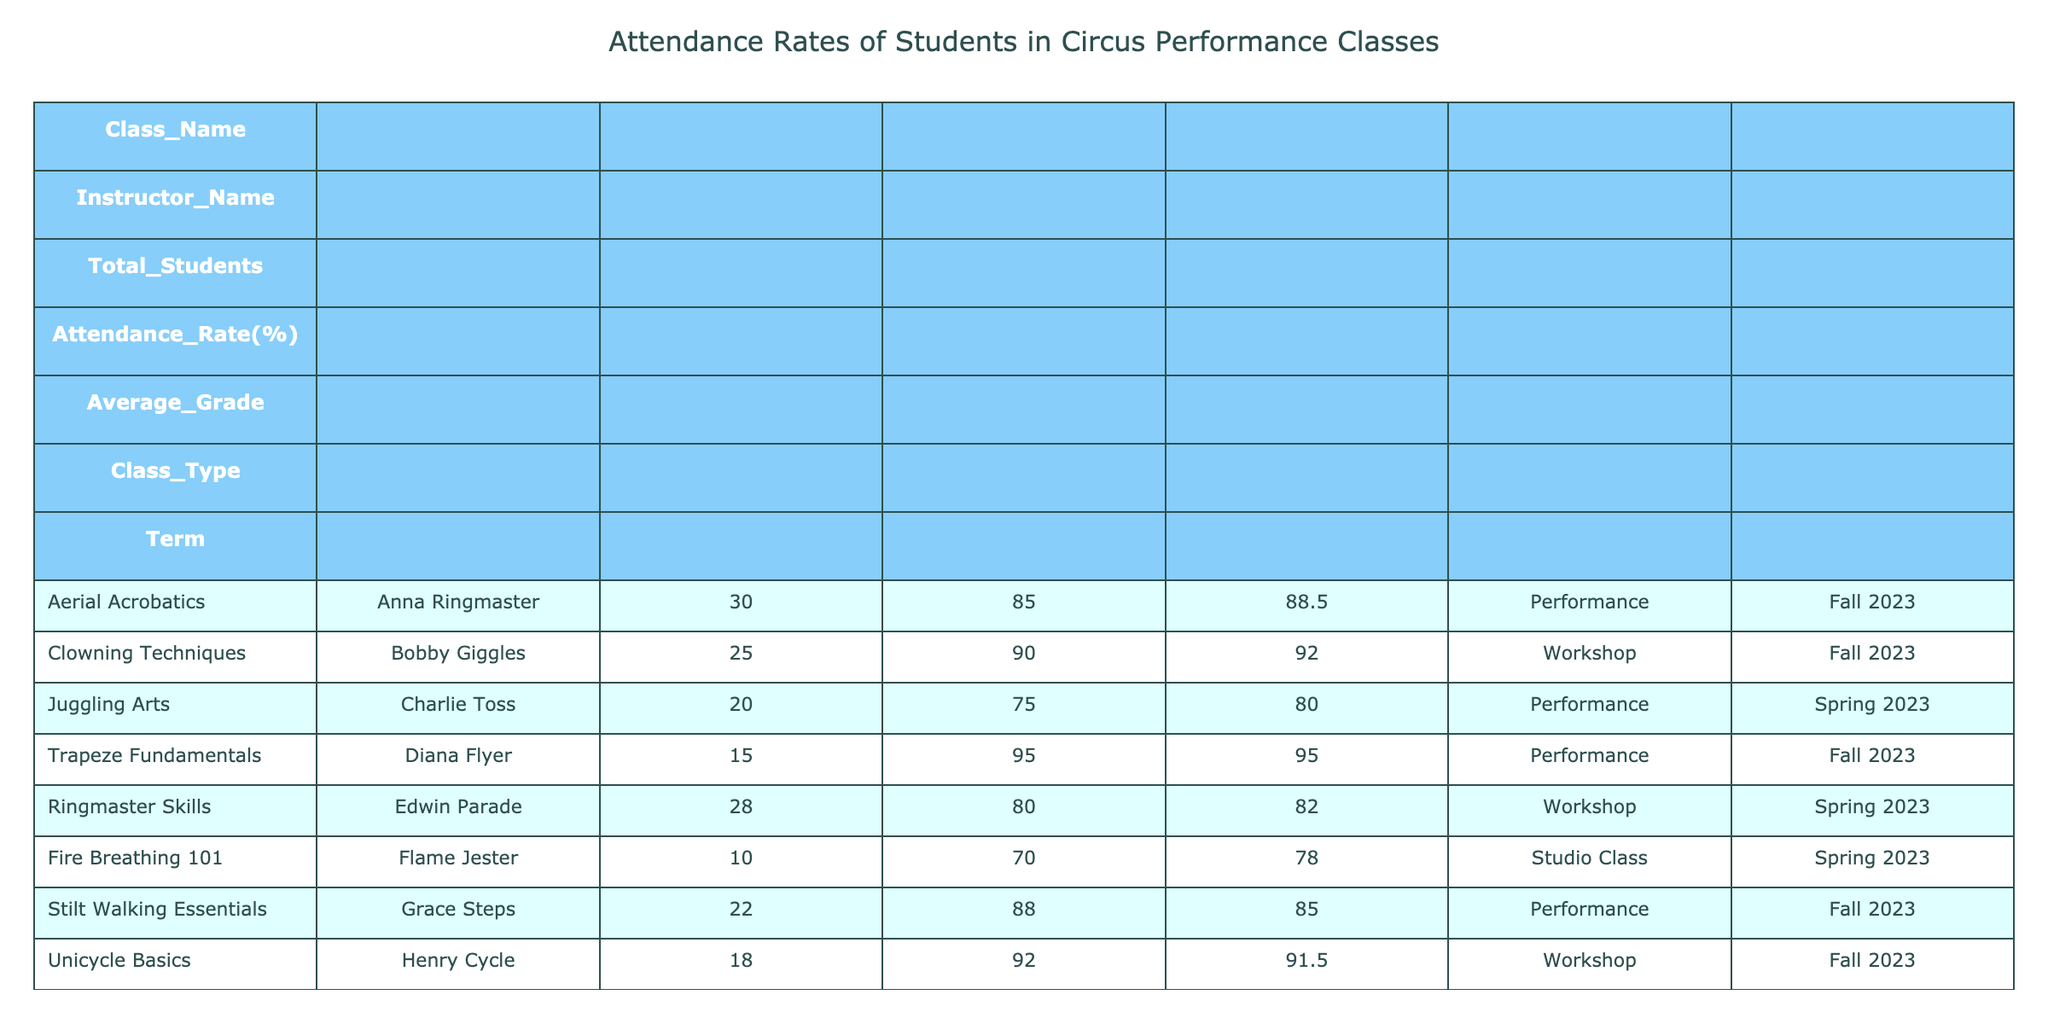What is the attendance rate for the Stilt Walking Essentials class? The attendance rate for Stilt Walking Essentials is given directly in the table, which indicates it as 88%.
Answer: 88 Which class has the highest attendance rate? The table shows the attendance rates for all classes, and by comparing them, Trapeze Fundamentals has the highest rate at 95%.
Answer: 95 What is the average attendance rate for the Performance classes? The attendance rates for the Performance classes are 85%, 75%, 95%, 88%, and 87%. Adding these together gives 85 + 75 + 95 + 88 + 87 = 430. There are 5 classes, so the average is 430/5 = 86%.
Answer: 86 Is the average grade for the Clowning Techniques class higher than that for the Aerial Acrobatics class? The average grade for Clowning Techniques is 92.0, while for Aerial Acrobatics it is 88.5. Since 92.0 > 88.5, the statement is true.
Answer: Yes What is the attendance difference between the Fire Breathing 101 class and the Unicycle Basics class? The attendance rate for Fire Breathing 101 is 70%, and for Unicycle Basics, it is 92%. The difference is 92 - 70 = 22%.
Answer: 22 How many total students are enrolled in the Performance classes? The Performance classes listed are Aerial Acrobatics (30), Juggling Arts (20), Trapeze Fundamentals (15), Stilt Walking Essentials (22), and Acrobatic Dance (26). Summing these gives 30 + 20 + 15 + 22 + 26 = 113 students.
Answer: 113 Are there more students in the Workshop classes than in the Studio Classes combined? There are 25 students in Clowning Techniques and 18 in Unicycle Basics for Workshop classes (25 + 18 = 43). For Studio Classes, there are 10 in Fire Breathing 101 and 14 in Animal Handling (10 + 14 = 24). Since 43 > 24, the statement is true.
Answer: Yes Which class has the lowest average grade and what is it? Looking at the average grades, Fire Breathing 101 has the lowest at 78.0. Thus, the class with the lowest average grade is Fire Breathing 101 and it is 78.0.
Answer: Fire Breathing 101, 78.0 What percentage of the students in the class with the least enrollment rate attended? The class with the least enrollment is Fire Breathing 101, with 10 students and an attendance rate of 70%. Therefore, 70% of the 10 students attended.
Answer: 70% 